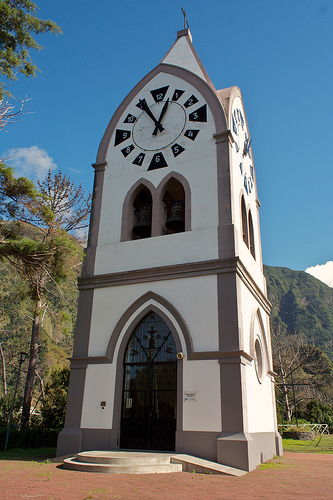What is in front of the hill? In front of the hill, there is a prominent clock tower. 